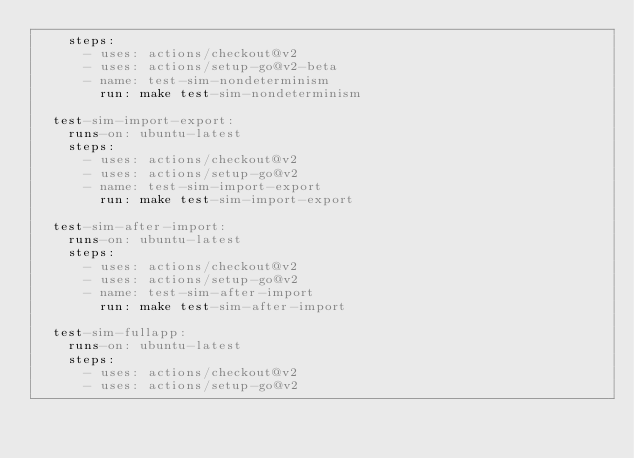Convert code to text. <code><loc_0><loc_0><loc_500><loc_500><_YAML_>    steps:
      - uses: actions/checkout@v2
      - uses: actions/setup-go@v2-beta
      - name: test-sim-nondeterminism
        run: make test-sim-nondeterminism

  test-sim-import-export:
    runs-on: ubuntu-latest
    steps:
      - uses: actions/checkout@v2
      - uses: actions/setup-go@v2
      - name: test-sim-import-export
        run: make test-sim-import-export

  test-sim-after-import:
    runs-on: ubuntu-latest
    steps:
      - uses: actions/checkout@v2
      - uses: actions/setup-go@v2
      - name: test-sim-after-import
        run: make test-sim-after-import

  test-sim-fullapp:
    runs-on: ubuntu-latest
    steps:
      - uses: actions/checkout@v2
      - uses: actions/setup-go@v2</code> 